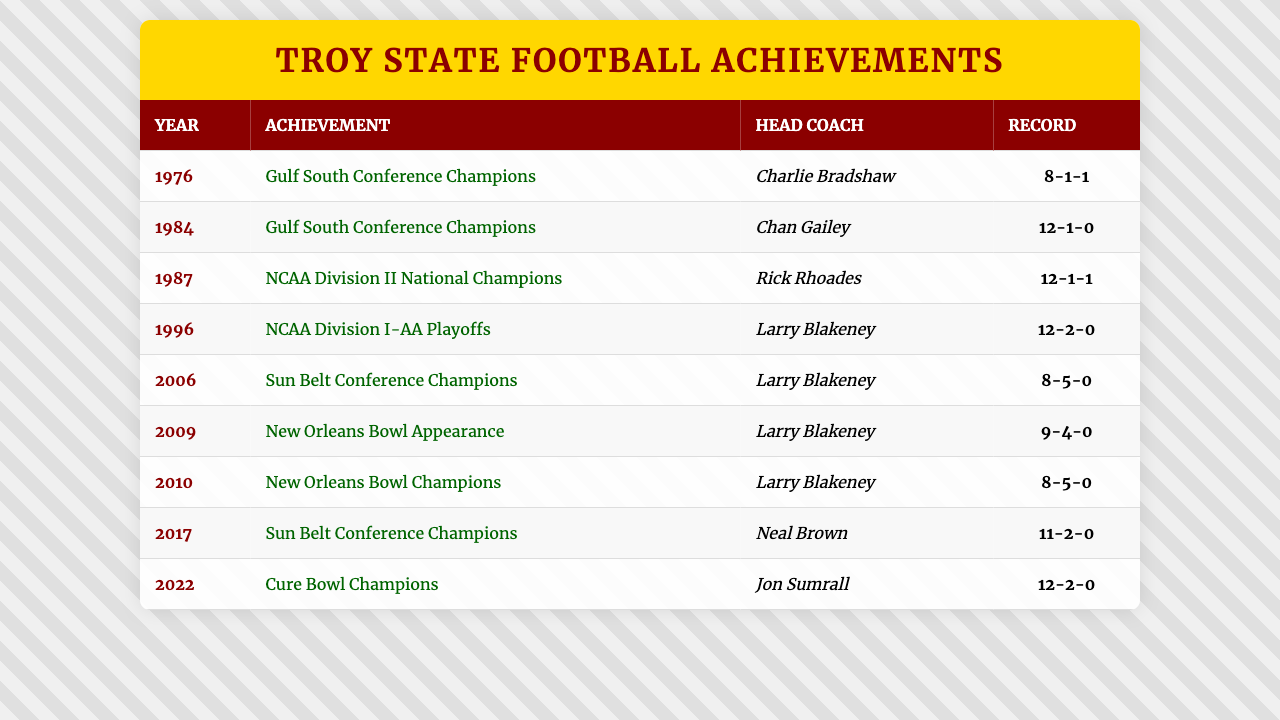What year did Troy State win the NCAA Division II National Championship? According to the table, the team won the NCAA Division II National Championship in 1987.
Answer: 1987 Who was the head coach in 2006 when Troy State won the Sun Belt Conference Championship? The table lists Larry Blakeney as the head coach in 2006 when the team won the Sun Belt Conference Championship.
Answer: Larry Blakeney How many times did Troy State appear in bowl games according to the table? The table shows two bowl game appearances: one in 2009 (New Orleans Bowl Appearance) and one in 2010 (New Orleans Bowl Champions), making it a total of 2 appearances.
Answer: 2 What was the best record achieved by Troy State during their championship years? Examining the records in the table, the best record (12-1-0) was achieved in 1984 when they were Gulf South Conference Champions.
Answer: 12-1-0 In what year did Troy State win the Cure Bowl? The table indicates that the Cure Bowl was won in 2022.
Answer: 2022 Was 1996 a year when Troy State won a conference championship? According to the table, 1996 was a year of participation in the NCAA Division I-AA Playoffs but does not list a conference championship for that year, so the answer is no.
Answer: No What is the average number of recorded wins in the years the team won championships? The records for championship years are 8, 12, 12, 8, 11, and 12. To find the average, sum the wins: (8 + 12 + 12 + 8 + 11 + 12) = 63. Divide by the number of championship wins: 63/6 = 10.5.
Answer: 10.5 Which head coach had the most achievements recorded in the table? Analyzing the entries, Larry Blakeney appears for three achievements (2006, 2009, 2010), while others appear less frequently.
Answer: Larry Blakeney How many total championships did Troy State win from 1976 to 2022? According to the table, Troy State won 5 championships: Gulf South Conference in 1976, Gulf South Conference in 1984, NCAA Division II National Championship in 1987, Sun Belt Conference in 2006, and Sun Belt Conference in 2017.
Answer: 5 What head coach led Troy State during their last championship win? The table states that Jon Sumrall was the head coach during the last championship win, which was the Cure Bowl in 2022.
Answer: Jon Sumrall 